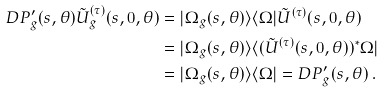<formula> <loc_0><loc_0><loc_500><loc_500>D P _ { g } ^ { \prime } ( s , \theta ) \tilde { U } _ { g } ^ { ( \tau ) } ( s , 0 , \theta ) & = | \Omega _ { g } ( s , \theta ) \rangle \langle \Omega | \tilde { U } ^ { ( \tau ) } ( s , 0 , \theta ) \\ & = | \Omega _ { g } ( s , \theta ) \rangle \langle ( \tilde { U } ^ { ( \tau ) } ( s , 0 , \theta ) ) ^ { * } \Omega | \\ & = | \Omega _ { g } ( s , \theta ) \rangle \langle \Omega | = D P _ { g } ^ { \prime } ( s , \theta ) \, .</formula> 